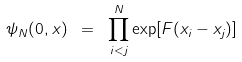Convert formula to latex. <formula><loc_0><loc_0><loc_500><loc_500>\psi _ { N } ( { 0 } , { x } ) \ = \ \prod ^ { N } _ { i < j } \exp [ F ( x _ { i } - x _ { j } ) ]</formula> 